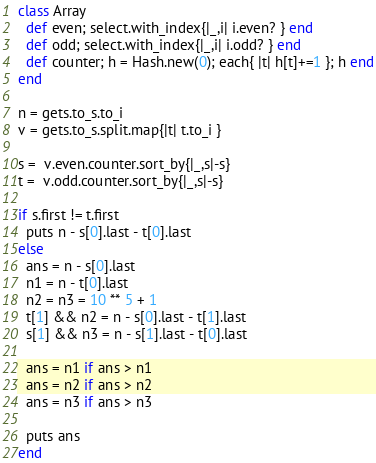Convert code to text. <code><loc_0><loc_0><loc_500><loc_500><_Ruby_>class Array
  def even; select.with_index{|_,i| i.even? } end
  def odd; select.with_index{|_,i| i.odd? } end
  def counter; h = Hash.new(0); each{ |t| h[t]+=1 }; h end
end

n = gets.to_s.to_i
v = gets.to_s.split.map{|t| t.to_i }

s =  v.even.counter.sort_by{|_,s|-s}
t =  v.odd.counter.sort_by{|_,s|-s}

if s.first != t.first
  puts n - s[0].last - t[0].last
else
  ans = n - s[0].last
  n1 = n - t[0].last
  n2 = n3 = 10 ** 5 + 1
  t[1] && n2 = n - s[0].last - t[1].last
  s[1] && n3 = n - s[1].last - t[0].last
  
  ans = n1 if ans > n1
  ans = n2 if ans > n2
  ans = n3 if ans > n3
  
  puts ans
end</code> 